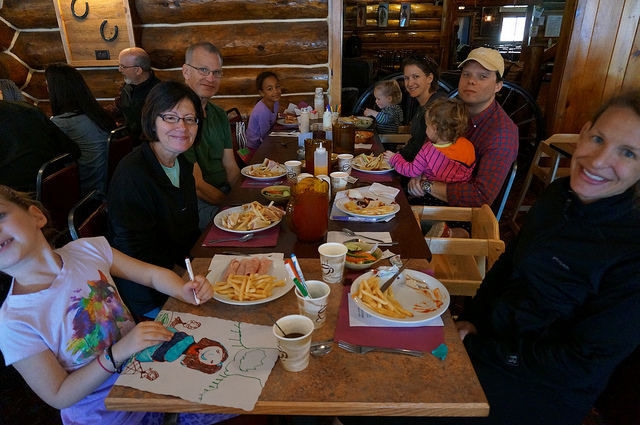<image>How old is the birthday person? It is ambiguous how old the birthday person is. What kind of business are the kids in? I don't know what kind of business the kids are in. It could possibly be a restaurant or they could be coloring. What is the woman pouring? I don't know what the woman is pouring. It could be water, soda, or nothing. What color is the sippy cup? There is no sippy cup in the image. However, it can be seen as white. What eating utensils are being used? I am not sure. It could be a fork, knife, spoon or no utensil at all. How old is the birthday person? It is not sure how old the birthday person is. It can be seen '32', '50', '20', '40' or '2'. What kind of business are the kids in? I am not sure what kind of business the kids are in. It can be a restaurant or something else. What color is the sippy cup? There is no sippy cup in the image. What is the woman pouring? I don't know what the woman is pouring. It can be water, soda or nothing. What eating utensils are being used? I don't know what eating utensils are being used. It can be seen 'none', 'knives', 'fork knife and spoon', or 'fork'. 